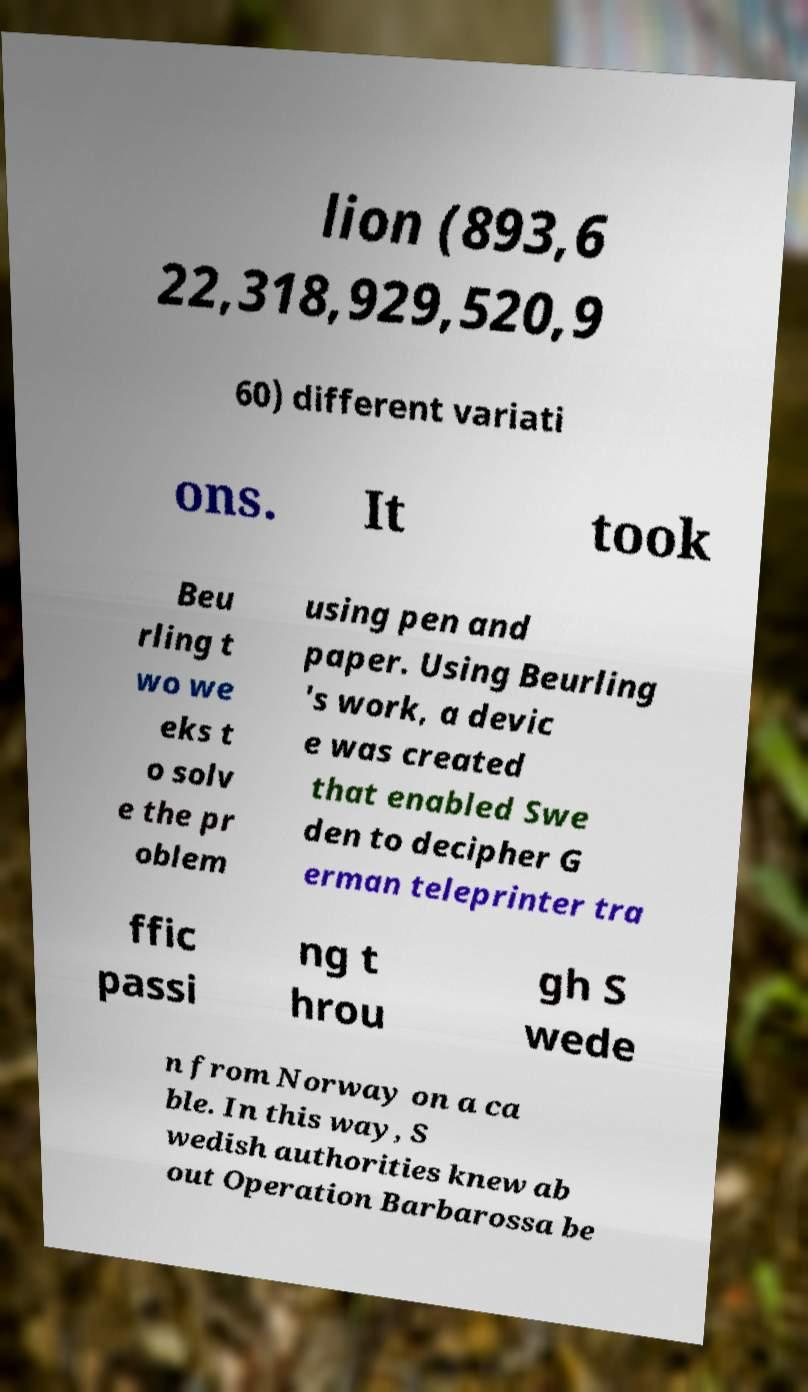For documentation purposes, I need the text within this image transcribed. Could you provide that? lion (893,6 22,318,929,520,9 60) different variati ons. It took Beu rling t wo we eks t o solv e the pr oblem using pen and paper. Using Beurling 's work, a devic e was created that enabled Swe den to decipher G erman teleprinter tra ffic passi ng t hrou gh S wede n from Norway on a ca ble. In this way, S wedish authorities knew ab out Operation Barbarossa be 